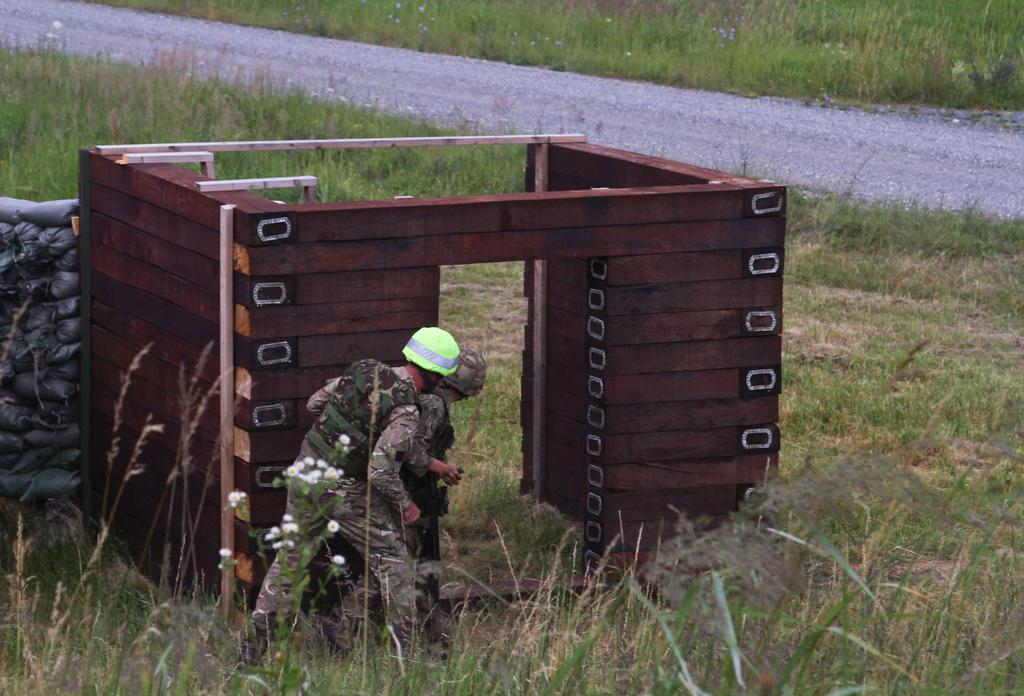How many people are in the image? There are two people in the image. What are the people wearing? The people are wearing military uniforms and helmets. What objects can be seen in the image besides the people? There is a wooden block, carry bags, grass, plants, flowers, and a road in the image. What grade of crack can be seen in the image? There is no crack present in the image. Where is the market located in the image? There is no market present in the image. 